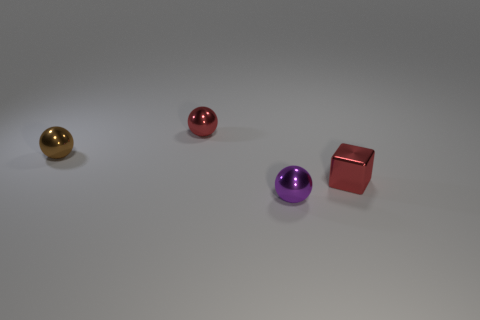Add 1 small things. How many objects exist? 5 Subtract all red balls. How many balls are left? 2 Subtract all red metal balls. How many balls are left? 2 Add 2 brown spheres. How many brown spheres exist? 3 Subtract 0 cyan balls. How many objects are left? 4 Subtract all balls. How many objects are left? 1 Subtract 1 blocks. How many blocks are left? 0 Subtract all cyan blocks. Subtract all purple cylinders. How many blocks are left? 1 Subtract all green blocks. How many purple spheres are left? 1 Subtract all small cyan shiny spheres. Subtract all tiny balls. How many objects are left? 1 